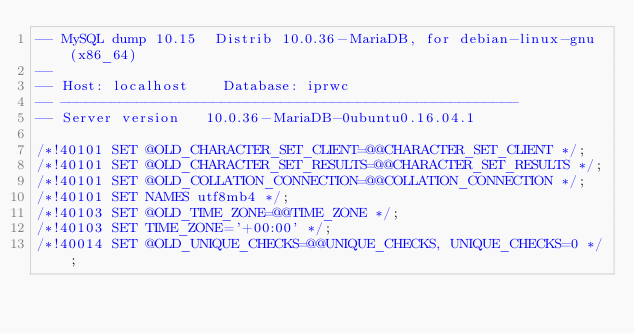Convert code to text. <code><loc_0><loc_0><loc_500><loc_500><_SQL_>-- MySQL dump 10.15  Distrib 10.0.36-MariaDB, for debian-linux-gnu (x86_64)
--
-- Host: localhost    Database: iprwc
-- ------------------------------------------------------
-- Server version	10.0.36-MariaDB-0ubuntu0.16.04.1

/*!40101 SET @OLD_CHARACTER_SET_CLIENT=@@CHARACTER_SET_CLIENT */;
/*!40101 SET @OLD_CHARACTER_SET_RESULTS=@@CHARACTER_SET_RESULTS */;
/*!40101 SET @OLD_COLLATION_CONNECTION=@@COLLATION_CONNECTION */;
/*!40101 SET NAMES utf8mb4 */;
/*!40103 SET @OLD_TIME_ZONE=@@TIME_ZONE */;
/*!40103 SET TIME_ZONE='+00:00' */;
/*!40014 SET @OLD_UNIQUE_CHECKS=@@UNIQUE_CHECKS, UNIQUE_CHECKS=0 */;</code> 